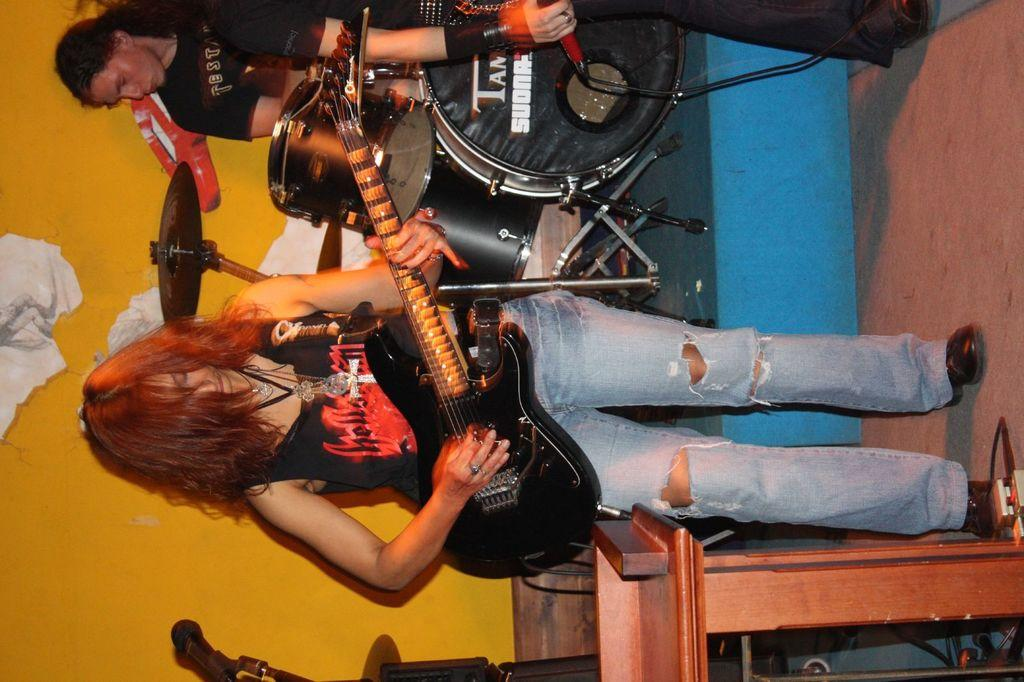What is the woman in the image holding? The woman is holding a guitar in the image. What is the person in the image holding? The person is holding a microphone in the image. What can be seen in the background of the image? There is a wall and a person near drums in the background of the image. What type of crime is being committed in the image? There is no indication of any crime being committed in the image. 